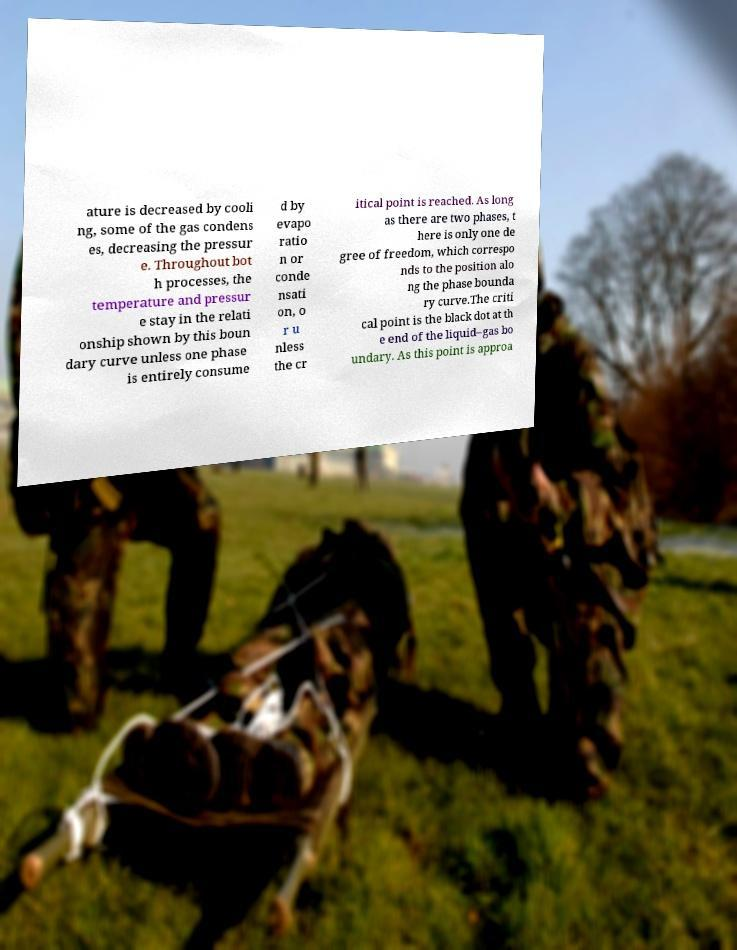Please read and relay the text visible in this image. What does it say? ature is decreased by cooli ng, some of the gas condens es, decreasing the pressur e. Throughout bot h processes, the temperature and pressur e stay in the relati onship shown by this boun dary curve unless one phase is entirely consume d by evapo ratio n or conde nsati on, o r u nless the cr itical point is reached. As long as there are two phases, t here is only one de gree of freedom, which correspo nds to the position alo ng the phase bounda ry curve.The criti cal point is the black dot at th e end of the liquid–gas bo undary. As this point is approa 